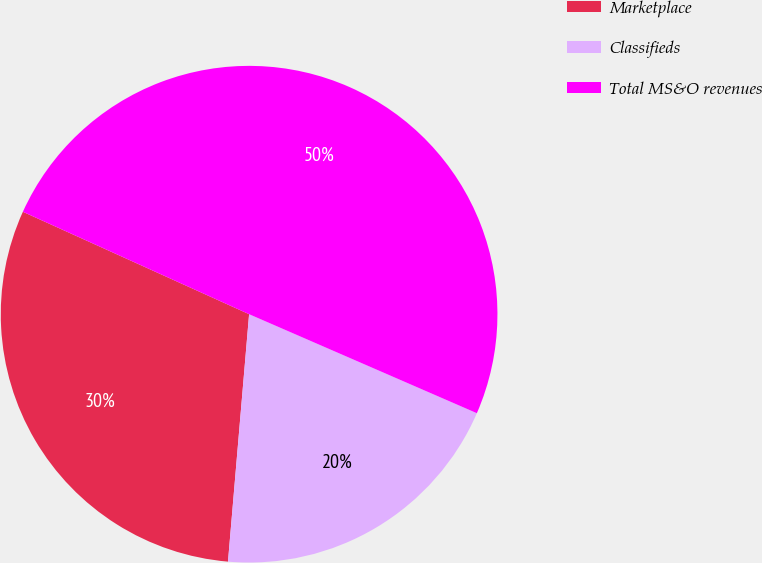Convert chart. <chart><loc_0><loc_0><loc_500><loc_500><pie_chart><fcel>Marketplace<fcel>Classifieds<fcel>Total MS&O revenues<nl><fcel>30.41%<fcel>19.83%<fcel>49.76%<nl></chart> 